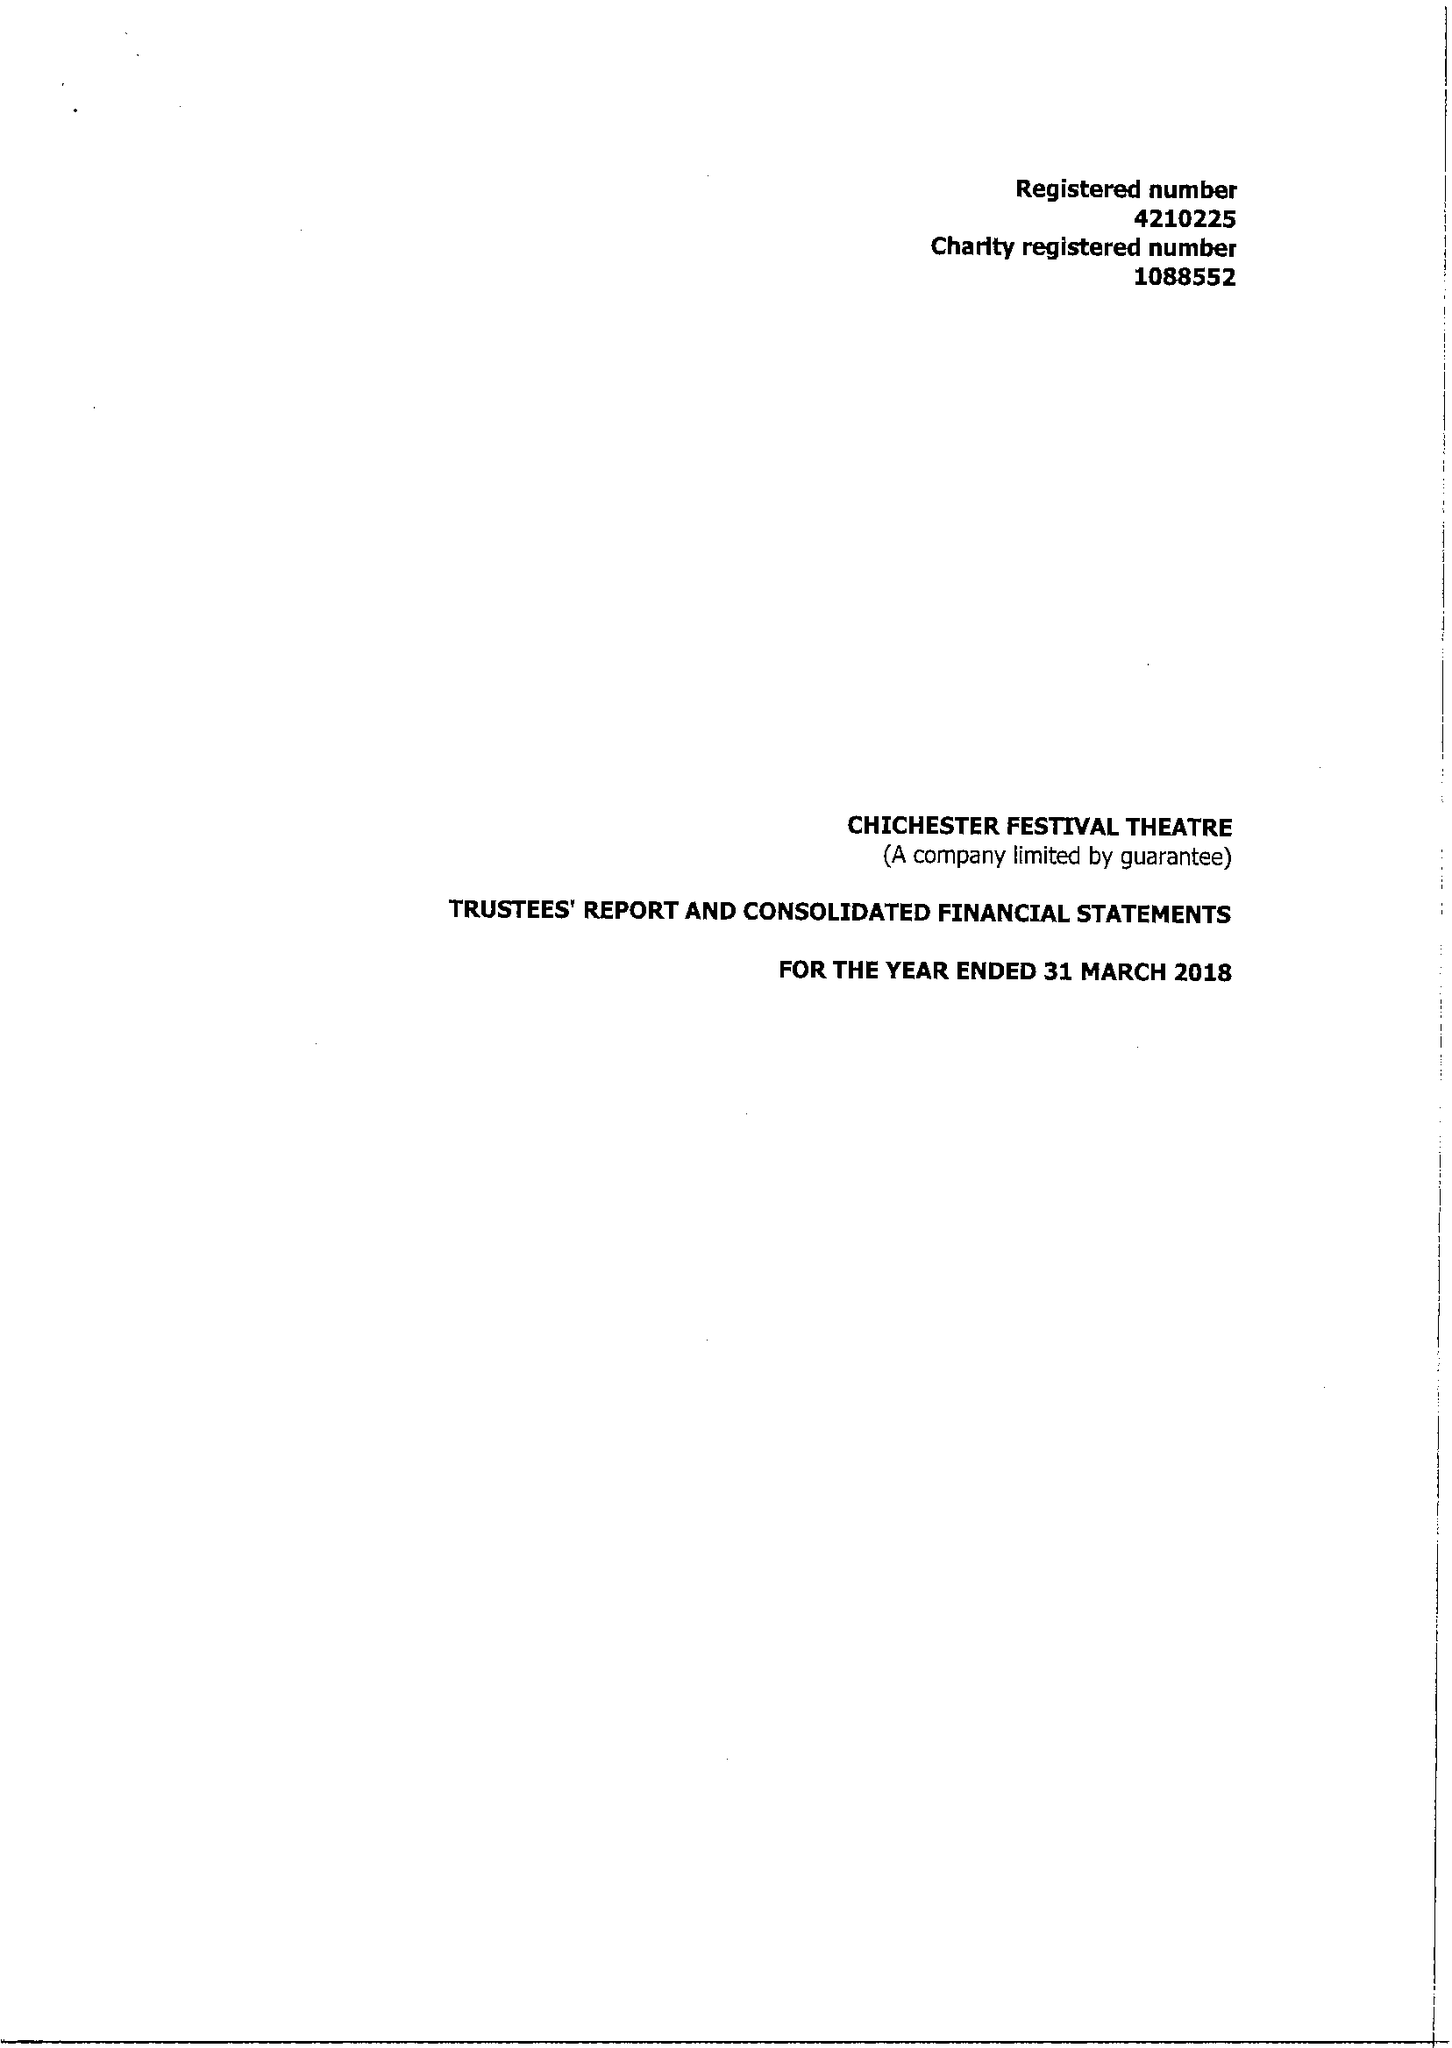What is the value for the income_annually_in_british_pounds?
Answer the question using a single word or phrase. 15721723.00 